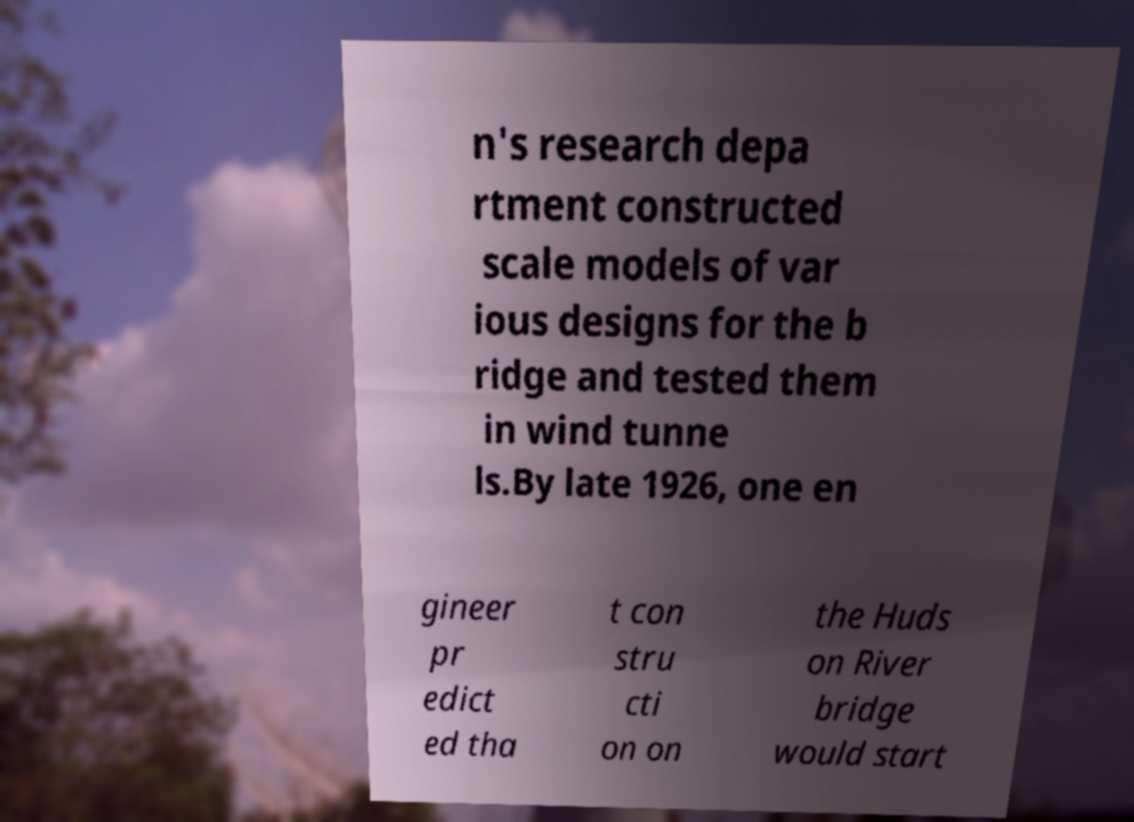Please read and relay the text visible in this image. What does it say? n's research depa rtment constructed scale models of var ious designs for the b ridge and tested them in wind tunne ls.By late 1926, one en gineer pr edict ed tha t con stru cti on on the Huds on River bridge would start 